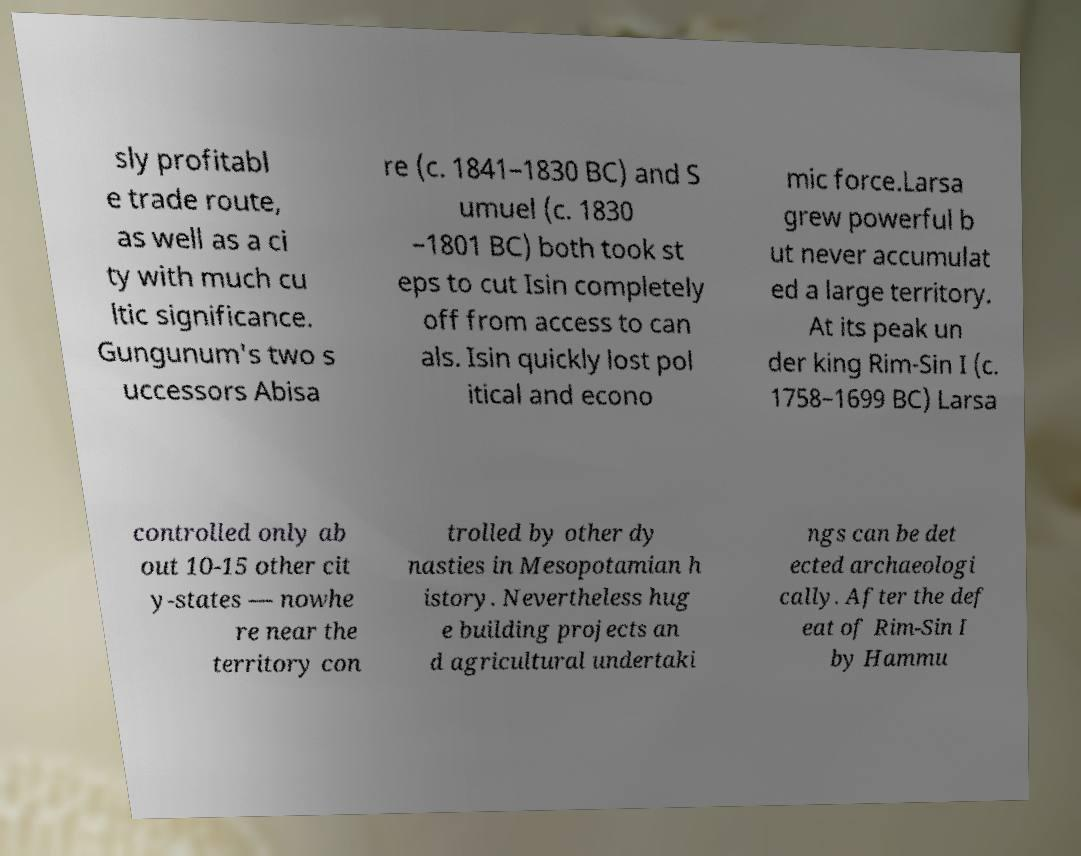Please read and relay the text visible in this image. What does it say? sly profitabl e trade route, as well as a ci ty with much cu ltic significance. Gungunum's two s uccessors Abisa re (c. 1841–1830 BC) and S umuel (c. 1830 –1801 BC) both took st eps to cut Isin completely off from access to can als. Isin quickly lost pol itical and econo mic force.Larsa grew powerful b ut never accumulat ed a large territory. At its peak un der king Rim-Sin I (c. 1758–1699 BC) Larsa controlled only ab out 10-15 other cit y-states — nowhe re near the territory con trolled by other dy nasties in Mesopotamian h istory. Nevertheless hug e building projects an d agricultural undertaki ngs can be det ected archaeologi cally. After the def eat of Rim-Sin I by Hammu 